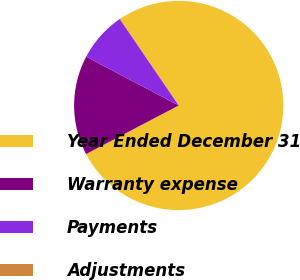Convert chart to OTSL. <chart><loc_0><loc_0><loc_500><loc_500><pie_chart><fcel>Year Ended December 31<fcel>Warranty expense<fcel>Payments<fcel>Adjustments<nl><fcel>76.76%<fcel>15.41%<fcel>7.75%<fcel>0.08%<nl></chart> 